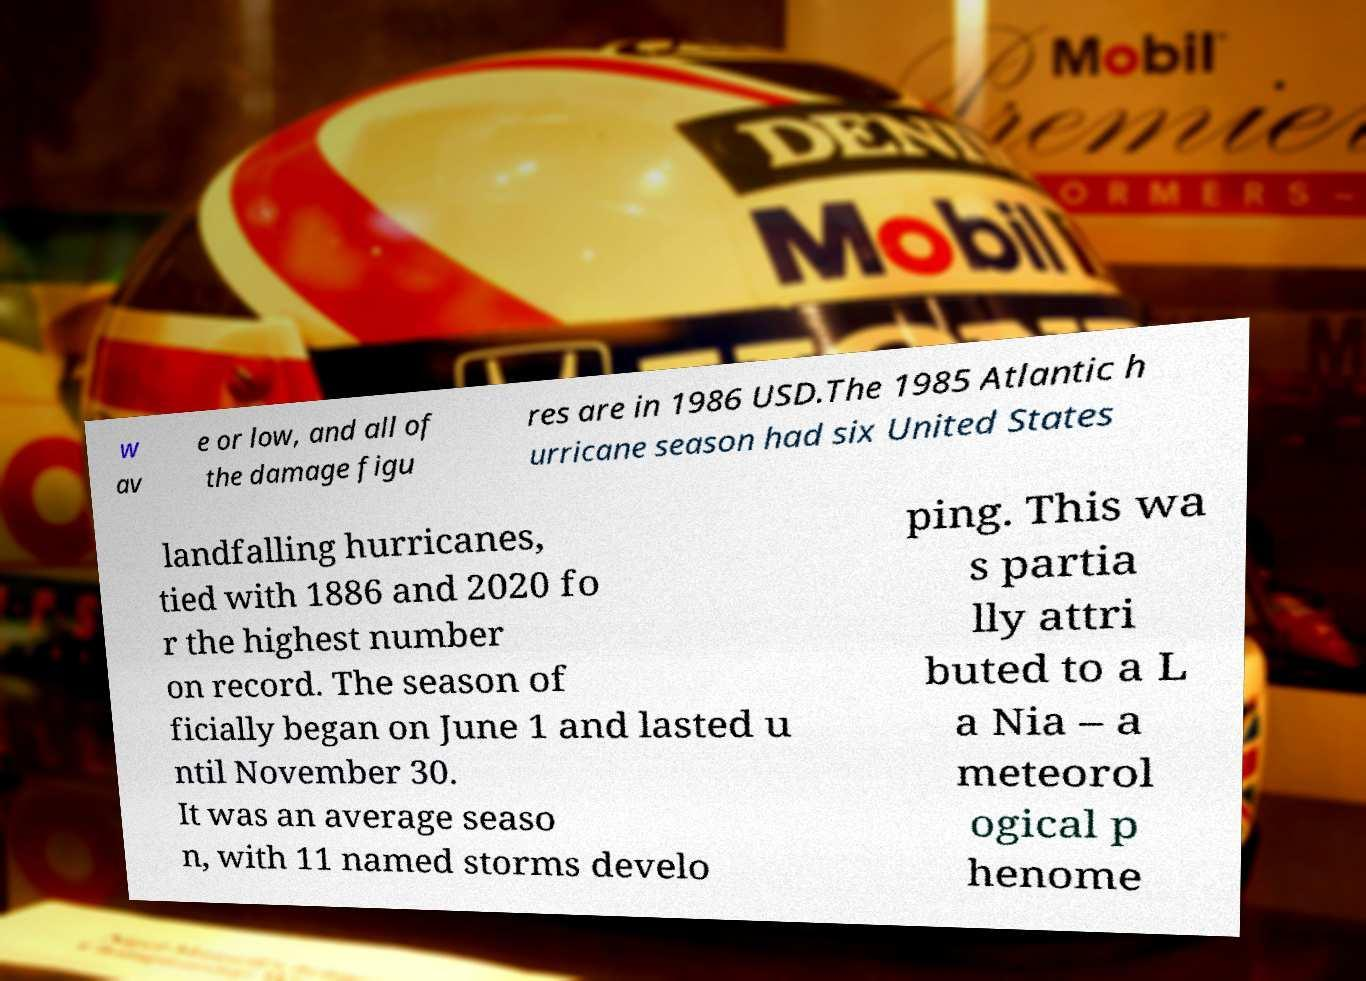Could you assist in decoding the text presented in this image and type it out clearly? w av e or low, and all of the damage figu res are in 1986 USD.The 1985 Atlantic h urricane season had six United States landfalling hurricanes, tied with 1886 and 2020 fo r the highest number on record. The season of ficially began on June 1 and lasted u ntil November 30. It was an average seaso n, with 11 named storms develo ping. This wa s partia lly attri buted to a L a Nia – a meteorol ogical p henome 